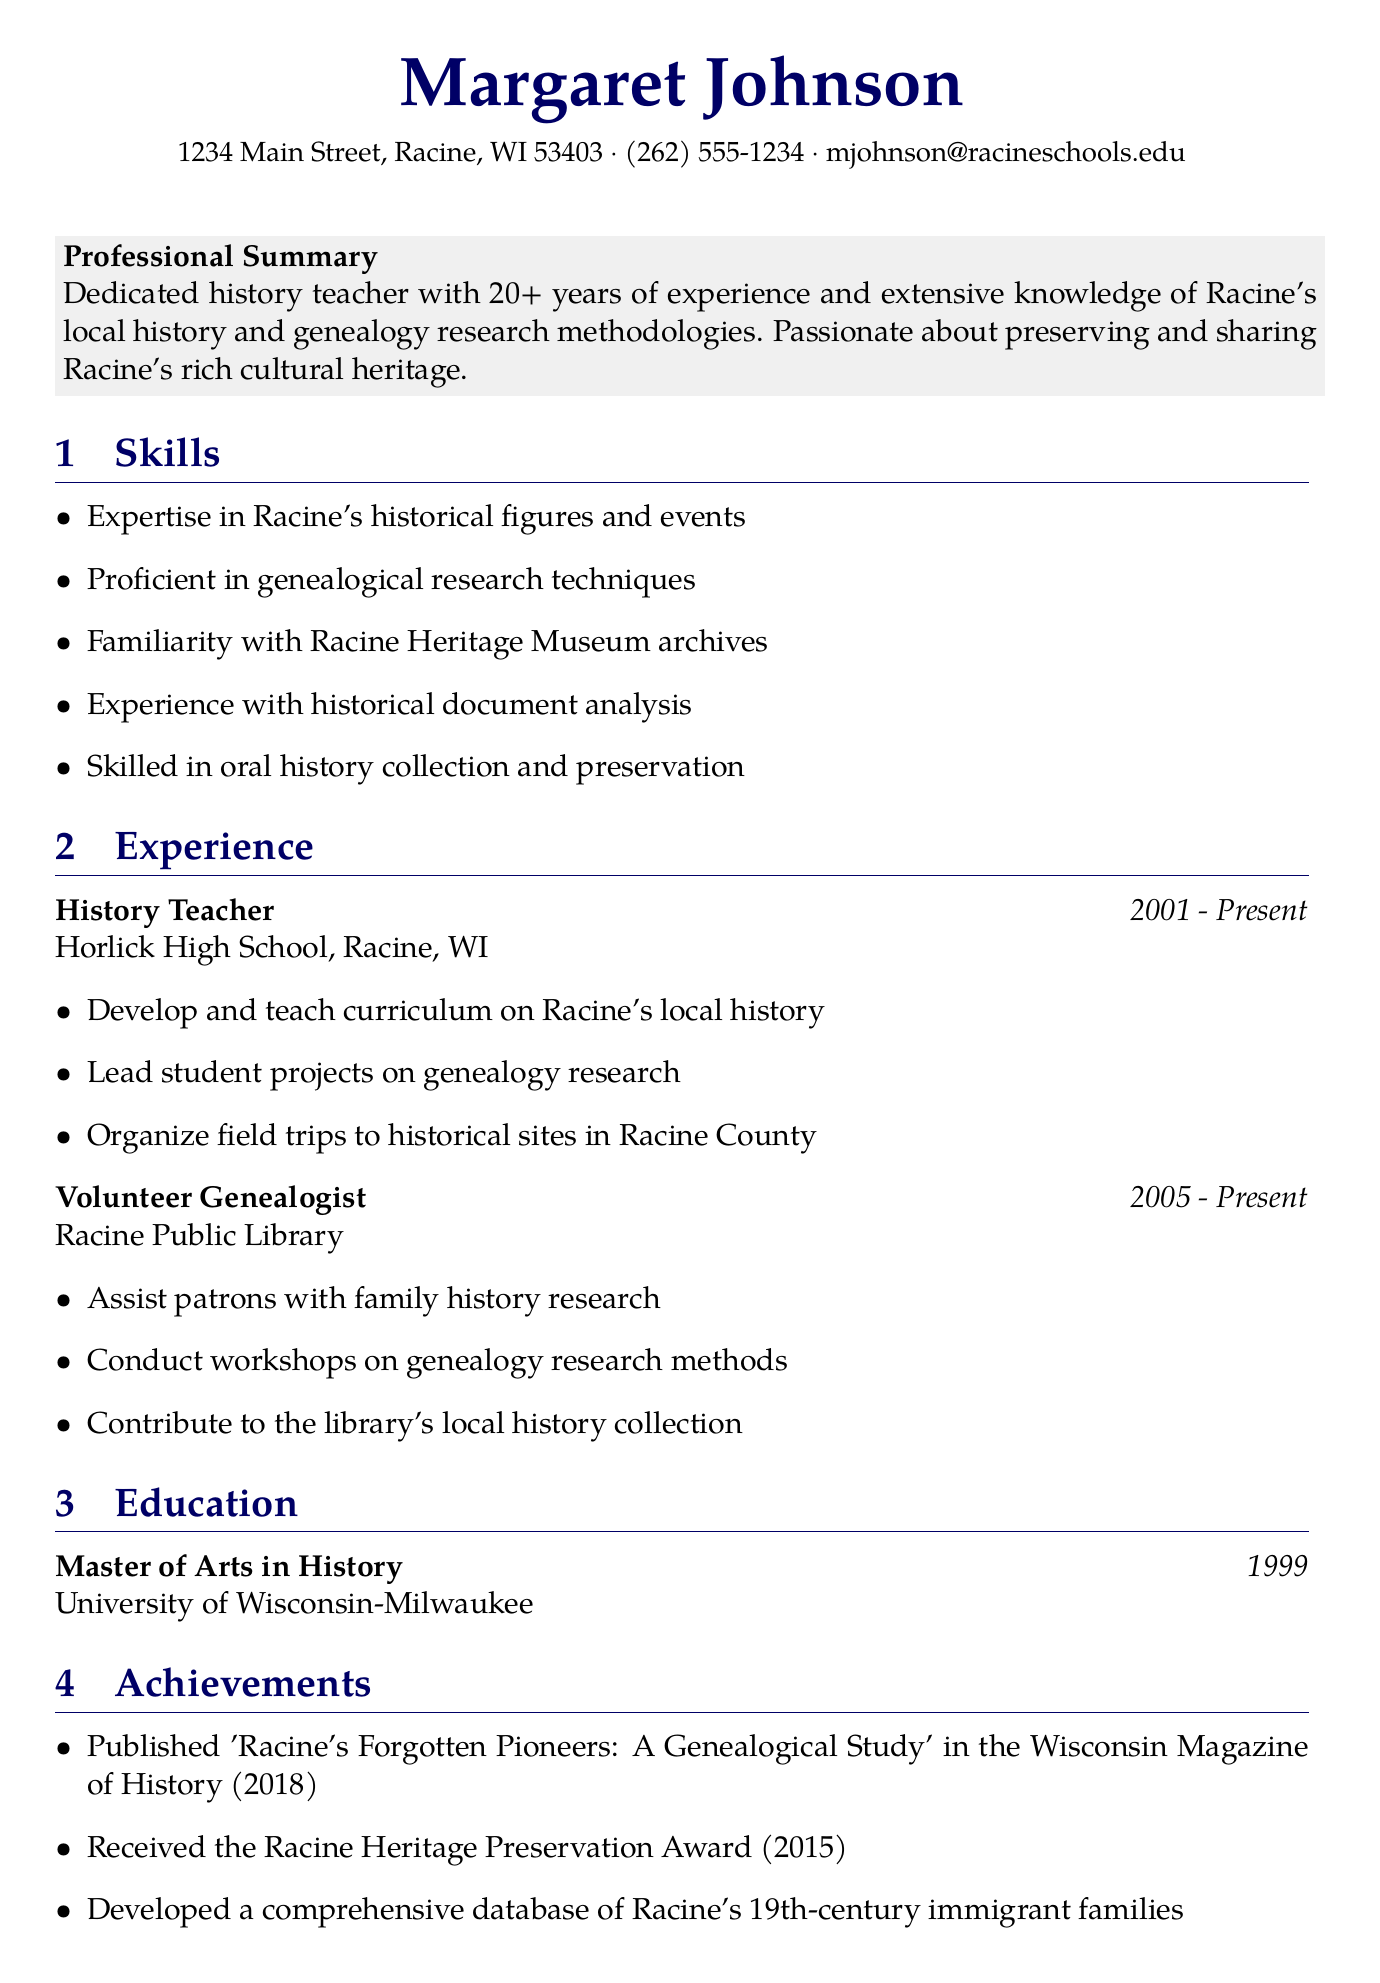What is the name of the individual? The individual's name is listed at the top of the document.
Answer: Margaret Johnson What is the degree earned by Margaret Johnson? The degree is mentioned in the education section of the document.
Answer: Master of Arts in History Which organization does Margaret Johnson work for? The current job title and organization are specified in the experience section.
Answer: Horlick High School What is the duration of her tenure as a history teacher? The duration is provided next to her title in the experience section.
Answer: 2001 - Present What is the title of the published work mentioned in the achievements? The title is specified in the achievements section of the document.
Answer: Racine's Forgotten Pioneers: A Genealogical Study How many years of experience does she have as a history teacher? The professional summary states her years of experience directly.
Answer: 20+ Which award did she receive in 2015? The achievement section lists the award received.
Answer: Racine Heritage Preservation Award What is one of her skills? The skills section contains a list of her qualifications.
Answer: Proficient in genealogical research techniques Which society is she a member of? The affiliations section lists several organizations she is part of.
Answer: Racine County Genealogical Society 